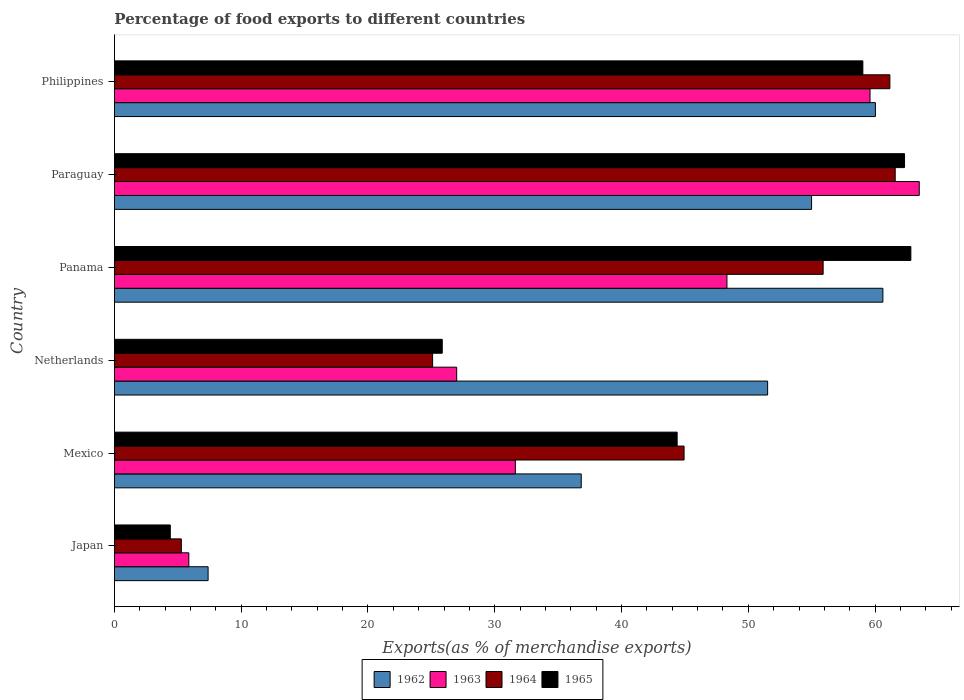How many different coloured bars are there?
Your response must be concise. 4. Are the number of bars on each tick of the Y-axis equal?
Your answer should be very brief. Yes. How many bars are there on the 4th tick from the top?
Provide a succinct answer. 4. What is the label of the 6th group of bars from the top?
Ensure brevity in your answer.  Japan. In how many cases, is the number of bars for a given country not equal to the number of legend labels?
Your answer should be very brief. 0. What is the percentage of exports to different countries in 1964 in Paraguay?
Your answer should be very brief. 61.59. Across all countries, what is the maximum percentage of exports to different countries in 1965?
Give a very brief answer. 62.82. Across all countries, what is the minimum percentage of exports to different countries in 1963?
Your answer should be very brief. 5.87. In which country was the percentage of exports to different countries in 1962 maximum?
Keep it short and to the point. Panama. What is the total percentage of exports to different countries in 1962 in the graph?
Provide a succinct answer. 271.37. What is the difference between the percentage of exports to different countries in 1962 in Japan and that in Mexico?
Your response must be concise. -29.43. What is the difference between the percentage of exports to different countries in 1962 in Japan and the percentage of exports to different countries in 1964 in Netherlands?
Your answer should be very brief. -17.71. What is the average percentage of exports to different countries in 1963 per country?
Give a very brief answer. 39.32. What is the difference between the percentage of exports to different countries in 1962 and percentage of exports to different countries in 1965 in Japan?
Offer a very short reply. 2.98. In how many countries, is the percentage of exports to different countries in 1963 greater than 4 %?
Your answer should be compact. 6. What is the ratio of the percentage of exports to different countries in 1963 in Japan to that in Mexico?
Offer a very short reply. 0.19. Is the difference between the percentage of exports to different countries in 1962 in Netherlands and Paraguay greater than the difference between the percentage of exports to different countries in 1965 in Netherlands and Paraguay?
Ensure brevity in your answer.  Yes. What is the difference between the highest and the second highest percentage of exports to different countries in 1963?
Your answer should be compact. 3.88. What is the difference between the highest and the lowest percentage of exports to different countries in 1963?
Keep it short and to the point. 57.62. Is it the case that in every country, the sum of the percentage of exports to different countries in 1964 and percentage of exports to different countries in 1962 is greater than the sum of percentage of exports to different countries in 1963 and percentage of exports to different countries in 1965?
Offer a very short reply. No. What does the 4th bar from the bottom in Mexico represents?
Your response must be concise. 1965. Are all the bars in the graph horizontal?
Offer a very short reply. Yes. What is the difference between two consecutive major ticks on the X-axis?
Your response must be concise. 10. Does the graph contain grids?
Offer a terse response. No. Where does the legend appear in the graph?
Provide a succinct answer. Bottom center. What is the title of the graph?
Provide a succinct answer. Percentage of food exports to different countries. What is the label or title of the X-axis?
Give a very brief answer. Exports(as % of merchandise exports). What is the Exports(as % of merchandise exports) of 1962 in Japan?
Offer a terse response. 7.39. What is the Exports(as % of merchandise exports) of 1963 in Japan?
Make the answer very short. 5.87. What is the Exports(as % of merchandise exports) in 1964 in Japan?
Give a very brief answer. 5.28. What is the Exports(as % of merchandise exports) in 1965 in Japan?
Make the answer very short. 4.41. What is the Exports(as % of merchandise exports) of 1962 in Mexico?
Offer a very short reply. 36.82. What is the Exports(as % of merchandise exports) in 1963 in Mexico?
Provide a succinct answer. 31.62. What is the Exports(as % of merchandise exports) of 1964 in Mexico?
Your response must be concise. 44.93. What is the Exports(as % of merchandise exports) in 1965 in Mexico?
Your answer should be very brief. 44.39. What is the Exports(as % of merchandise exports) in 1962 in Netherlands?
Ensure brevity in your answer.  51.52. What is the Exports(as % of merchandise exports) in 1963 in Netherlands?
Your answer should be compact. 27. What is the Exports(as % of merchandise exports) in 1964 in Netherlands?
Offer a very short reply. 25.1. What is the Exports(as % of merchandise exports) of 1965 in Netherlands?
Keep it short and to the point. 25.86. What is the Exports(as % of merchandise exports) in 1962 in Panama?
Provide a succinct answer. 60.62. What is the Exports(as % of merchandise exports) in 1963 in Panama?
Make the answer very short. 48.32. What is the Exports(as % of merchandise exports) of 1964 in Panama?
Make the answer very short. 55.9. What is the Exports(as % of merchandise exports) of 1965 in Panama?
Give a very brief answer. 62.82. What is the Exports(as % of merchandise exports) in 1962 in Paraguay?
Your answer should be very brief. 54.99. What is the Exports(as % of merchandise exports) of 1963 in Paraguay?
Provide a short and direct response. 63.48. What is the Exports(as % of merchandise exports) in 1964 in Paraguay?
Your response must be concise. 61.59. What is the Exports(as % of merchandise exports) in 1965 in Paraguay?
Give a very brief answer. 62.32. What is the Exports(as % of merchandise exports) of 1962 in Philippines?
Ensure brevity in your answer.  60.03. What is the Exports(as % of merchandise exports) of 1963 in Philippines?
Provide a succinct answer. 59.6. What is the Exports(as % of merchandise exports) in 1964 in Philippines?
Offer a terse response. 61.17. What is the Exports(as % of merchandise exports) in 1965 in Philippines?
Offer a terse response. 59.04. Across all countries, what is the maximum Exports(as % of merchandise exports) in 1962?
Your answer should be compact. 60.62. Across all countries, what is the maximum Exports(as % of merchandise exports) in 1963?
Offer a very short reply. 63.48. Across all countries, what is the maximum Exports(as % of merchandise exports) in 1964?
Ensure brevity in your answer.  61.59. Across all countries, what is the maximum Exports(as % of merchandise exports) in 1965?
Your response must be concise. 62.82. Across all countries, what is the minimum Exports(as % of merchandise exports) in 1962?
Offer a very short reply. 7.39. Across all countries, what is the minimum Exports(as % of merchandise exports) of 1963?
Provide a succinct answer. 5.87. Across all countries, what is the minimum Exports(as % of merchandise exports) in 1964?
Make the answer very short. 5.28. Across all countries, what is the minimum Exports(as % of merchandise exports) of 1965?
Your answer should be very brief. 4.41. What is the total Exports(as % of merchandise exports) of 1962 in the graph?
Your response must be concise. 271.37. What is the total Exports(as % of merchandise exports) in 1963 in the graph?
Offer a terse response. 235.89. What is the total Exports(as % of merchandise exports) of 1964 in the graph?
Provide a succinct answer. 253.97. What is the total Exports(as % of merchandise exports) in 1965 in the graph?
Make the answer very short. 258.83. What is the difference between the Exports(as % of merchandise exports) in 1962 in Japan and that in Mexico?
Give a very brief answer. -29.43. What is the difference between the Exports(as % of merchandise exports) of 1963 in Japan and that in Mexico?
Offer a very short reply. -25.75. What is the difference between the Exports(as % of merchandise exports) in 1964 in Japan and that in Mexico?
Ensure brevity in your answer.  -39.66. What is the difference between the Exports(as % of merchandise exports) of 1965 in Japan and that in Mexico?
Your answer should be very brief. -39.98. What is the difference between the Exports(as % of merchandise exports) of 1962 in Japan and that in Netherlands?
Offer a very short reply. -44.13. What is the difference between the Exports(as % of merchandise exports) of 1963 in Japan and that in Netherlands?
Offer a very short reply. -21.13. What is the difference between the Exports(as % of merchandise exports) of 1964 in Japan and that in Netherlands?
Provide a succinct answer. -19.82. What is the difference between the Exports(as % of merchandise exports) of 1965 in Japan and that in Netherlands?
Offer a terse response. -21.45. What is the difference between the Exports(as % of merchandise exports) of 1962 in Japan and that in Panama?
Ensure brevity in your answer.  -53.23. What is the difference between the Exports(as % of merchandise exports) of 1963 in Japan and that in Panama?
Offer a very short reply. -42.45. What is the difference between the Exports(as % of merchandise exports) of 1964 in Japan and that in Panama?
Offer a terse response. -50.63. What is the difference between the Exports(as % of merchandise exports) in 1965 in Japan and that in Panama?
Provide a short and direct response. -58.42. What is the difference between the Exports(as % of merchandise exports) in 1962 in Japan and that in Paraguay?
Provide a succinct answer. -47.6. What is the difference between the Exports(as % of merchandise exports) in 1963 in Japan and that in Paraguay?
Provide a short and direct response. -57.62. What is the difference between the Exports(as % of merchandise exports) of 1964 in Japan and that in Paraguay?
Ensure brevity in your answer.  -56.31. What is the difference between the Exports(as % of merchandise exports) in 1965 in Japan and that in Paraguay?
Your answer should be very brief. -57.92. What is the difference between the Exports(as % of merchandise exports) of 1962 in Japan and that in Philippines?
Your answer should be compact. -52.64. What is the difference between the Exports(as % of merchandise exports) in 1963 in Japan and that in Philippines?
Your answer should be compact. -53.73. What is the difference between the Exports(as % of merchandise exports) of 1964 in Japan and that in Philippines?
Give a very brief answer. -55.89. What is the difference between the Exports(as % of merchandise exports) of 1965 in Japan and that in Philippines?
Give a very brief answer. -54.63. What is the difference between the Exports(as % of merchandise exports) in 1962 in Mexico and that in Netherlands?
Ensure brevity in your answer.  -14.7. What is the difference between the Exports(as % of merchandise exports) of 1963 in Mexico and that in Netherlands?
Your response must be concise. 4.63. What is the difference between the Exports(as % of merchandise exports) in 1964 in Mexico and that in Netherlands?
Provide a short and direct response. 19.84. What is the difference between the Exports(as % of merchandise exports) of 1965 in Mexico and that in Netherlands?
Make the answer very short. 18.53. What is the difference between the Exports(as % of merchandise exports) of 1962 in Mexico and that in Panama?
Keep it short and to the point. -23.79. What is the difference between the Exports(as % of merchandise exports) of 1963 in Mexico and that in Panama?
Provide a succinct answer. -16.69. What is the difference between the Exports(as % of merchandise exports) in 1964 in Mexico and that in Panama?
Make the answer very short. -10.97. What is the difference between the Exports(as % of merchandise exports) in 1965 in Mexico and that in Panama?
Provide a short and direct response. -18.44. What is the difference between the Exports(as % of merchandise exports) in 1962 in Mexico and that in Paraguay?
Ensure brevity in your answer.  -18.17. What is the difference between the Exports(as % of merchandise exports) in 1963 in Mexico and that in Paraguay?
Ensure brevity in your answer.  -31.86. What is the difference between the Exports(as % of merchandise exports) in 1964 in Mexico and that in Paraguay?
Give a very brief answer. -16.65. What is the difference between the Exports(as % of merchandise exports) of 1965 in Mexico and that in Paraguay?
Offer a very short reply. -17.94. What is the difference between the Exports(as % of merchandise exports) in 1962 in Mexico and that in Philippines?
Ensure brevity in your answer.  -23.2. What is the difference between the Exports(as % of merchandise exports) of 1963 in Mexico and that in Philippines?
Offer a very short reply. -27.98. What is the difference between the Exports(as % of merchandise exports) in 1964 in Mexico and that in Philippines?
Offer a terse response. -16.23. What is the difference between the Exports(as % of merchandise exports) in 1965 in Mexico and that in Philippines?
Your response must be concise. -14.65. What is the difference between the Exports(as % of merchandise exports) of 1962 in Netherlands and that in Panama?
Ensure brevity in your answer.  -9.09. What is the difference between the Exports(as % of merchandise exports) in 1963 in Netherlands and that in Panama?
Provide a succinct answer. -21.32. What is the difference between the Exports(as % of merchandise exports) in 1964 in Netherlands and that in Panama?
Your answer should be very brief. -30.81. What is the difference between the Exports(as % of merchandise exports) of 1965 in Netherlands and that in Panama?
Ensure brevity in your answer.  -36.96. What is the difference between the Exports(as % of merchandise exports) of 1962 in Netherlands and that in Paraguay?
Make the answer very short. -3.47. What is the difference between the Exports(as % of merchandise exports) in 1963 in Netherlands and that in Paraguay?
Offer a terse response. -36.49. What is the difference between the Exports(as % of merchandise exports) of 1964 in Netherlands and that in Paraguay?
Your answer should be very brief. -36.49. What is the difference between the Exports(as % of merchandise exports) of 1965 in Netherlands and that in Paraguay?
Ensure brevity in your answer.  -36.47. What is the difference between the Exports(as % of merchandise exports) in 1962 in Netherlands and that in Philippines?
Give a very brief answer. -8.5. What is the difference between the Exports(as % of merchandise exports) in 1963 in Netherlands and that in Philippines?
Your answer should be very brief. -32.6. What is the difference between the Exports(as % of merchandise exports) of 1964 in Netherlands and that in Philippines?
Give a very brief answer. -36.07. What is the difference between the Exports(as % of merchandise exports) of 1965 in Netherlands and that in Philippines?
Offer a terse response. -33.18. What is the difference between the Exports(as % of merchandise exports) of 1962 in Panama and that in Paraguay?
Offer a very short reply. 5.62. What is the difference between the Exports(as % of merchandise exports) of 1963 in Panama and that in Paraguay?
Make the answer very short. -15.17. What is the difference between the Exports(as % of merchandise exports) in 1964 in Panama and that in Paraguay?
Your answer should be very brief. -5.68. What is the difference between the Exports(as % of merchandise exports) of 1965 in Panama and that in Paraguay?
Your answer should be compact. 0.5. What is the difference between the Exports(as % of merchandise exports) in 1962 in Panama and that in Philippines?
Your answer should be very brief. 0.59. What is the difference between the Exports(as % of merchandise exports) in 1963 in Panama and that in Philippines?
Offer a terse response. -11.29. What is the difference between the Exports(as % of merchandise exports) in 1964 in Panama and that in Philippines?
Your response must be concise. -5.26. What is the difference between the Exports(as % of merchandise exports) of 1965 in Panama and that in Philippines?
Provide a short and direct response. 3.79. What is the difference between the Exports(as % of merchandise exports) in 1962 in Paraguay and that in Philippines?
Offer a very short reply. -5.03. What is the difference between the Exports(as % of merchandise exports) in 1963 in Paraguay and that in Philippines?
Your response must be concise. 3.88. What is the difference between the Exports(as % of merchandise exports) of 1964 in Paraguay and that in Philippines?
Give a very brief answer. 0.42. What is the difference between the Exports(as % of merchandise exports) in 1965 in Paraguay and that in Philippines?
Offer a very short reply. 3.29. What is the difference between the Exports(as % of merchandise exports) in 1962 in Japan and the Exports(as % of merchandise exports) in 1963 in Mexico?
Offer a terse response. -24.23. What is the difference between the Exports(as % of merchandise exports) of 1962 in Japan and the Exports(as % of merchandise exports) of 1964 in Mexico?
Provide a short and direct response. -37.55. What is the difference between the Exports(as % of merchandise exports) of 1962 in Japan and the Exports(as % of merchandise exports) of 1965 in Mexico?
Ensure brevity in your answer.  -37. What is the difference between the Exports(as % of merchandise exports) in 1963 in Japan and the Exports(as % of merchandise exports) in 1964 in Mexico?
Make the answer very short. -39.07. What is the difference between the Exports(as % of merchandise exports) of 1963 in Japan and the Exports(as % of merchandise exports) of 1965 in Mexico?
Offer a very short reply. -38.52. What is the difference between the Exports(as % of merchandise exports) of 1964 in Japan and the Exports(as % of merchandise exports) of 1965 in Mexico?
Your response must be concise. -39.11. What is the difference between the Exports(as % of merchandise exports) in 1962 in Japan and the Exports(as % of merchandise exports) in 1963 in Netherlands?
Your answer should be very brief. -19.61. What is the difference between the Exports(as % of merchandise exports) of 1962 in Japan and the Exports(as % of merchandise exports) of 1964 in Netherlands?
Your response must be concise. -17.71. What is the difference between the Exports(as % of merchandise exports) in 1962 in Japan and the Exports(as % of merchandise exports) in 1965 in Netherlands?
Ensure brevity in your answer.  -18.47. What is the difference between the Exports(as % of merchandise exports) of 1963 in Japan and the Exports(as % of merchandise exports) of 1964 in Netherlands?
Keep it short and to the point. -19.23. What is the difference between the Exports(as % of merchandise exports) in 1963 in Japan and the Exports(as % of merchandise exports) in 1965 in Netherlands?
Provide a short and direct response. -19.99. What is the difference between the Exports(as % of merchandise exports) of 1964 in Japan and the Exports(as % of merchandise exports) of 1965 in Netherlands?
Make the answer very short. -20.58. What is the difference between the Exports(as % of merchandise exports) in 1962 in Japan and the Exports(as % of merchandise exports) in 1963 in Panama?
Make the answer very short. -40.93. What is the difference between the Exports(as % of merchandise exports) of 1962 in Japan and the Exports(as % of merchandise exports) of 1964 in Panama?
Your response must be concise. -48.51. What is the difference between the Exports(as % of merchandise exports) in 1962 in Japan and the Exports(as % of merchandise exports) in 1965 in Panama?
Offer a terse response. -55.43. What is the difference between the Exports(as % of merchandise exports) of 1963 in Japan and the Exports(as % of merchandise exports) of 1964 in Panama?
Keep it short and to the point. -50.03. What is the difference between the Exports(as % of merchandise exports) in 1963 in Japan and the Exports(as % of merchandise exports) in 1965 in Panama?
Give a very brief answer. -56.95. What is the difference between the Exports(as % of merchandise exports) of 1964 in Japan and the Exports(as % of merchandise exports) of 1965 in Panama?
Give a very brief answer. -57.54. What is the difference between the Exports(as % of merchandise exports) of 1962 in Japan and the Exports(as % of merchandise exports) of 1963 in Paraguay?
Give a very brief answer. -56.1. What is the difference between the Exports(as % of merchandise exports) of 1962 in Japan and the Exports(as % of merchandise exports) of 1964 in Paraguay?
Give a very brief answer. -54.2. What is the difference between the Exports(as % of merchandise exports) in 1962 in Japan and the Exports(as % of merchandise exports) in 1965 in Paraguay?
Offer a terse response. -54.94. What is the difference between the Exports(as % of merchandise exports) in 1963 in Japan and the Exports(as % of merchandise exports) in 1964 in Paraguay?
Your answer should be very brief. -55.72. What is the difference between the Exports(as % of merchandise exports) in 1963 in Japan and the Exports(as % of merchandise exports) in 1965 in Paraguay?
Provide a succinct answer. -56.46. What is the difference between the Exports(as % of merchandise exports) in 1964 in Japan and the Exports(as % of merchandise exports) in 1965 in Paraguay?
Offer a very short reply. -57.05. What is the difference between the Exports(as % of merchandise exports) in 1962 in Japan and the Exports(as % of merchandise exports) in 1963 in Philippines?
Ensure brevity in your answer.  -52.21. What is the difference between the Exports(as % of merchandise exports) of 1962 in Japan and the Exports(as % of merchandise exports) of 1964 in Philippines?
Ensure brevity in your answer.  -53.78. What is the difference between the Exports(as % of merchandise exports) of 1962 in Japan and the Exports(as % of merchandise exports) of 1965 in Philippines?
Offer a very short reply. -51.65. What is the difference between the Exports(as % of merchandise exports) in 1963 in Japan and the Exports(as % of merchandise exports) in 1964 in Philippines?
Your answer should be compact. -55.3. What is the difference between the Exports(as % of merchandise exports) in 1963 in Japan and the Exports(as % of merchandise exports) in 1965 in Philippines?
Provide a short and direct response. -53.17. What is the difference between the Exports(as % of merchandise exports) in 1964 in Japan and the Exports(as % of merchandise exports) in 1965 in Philippines?
Your response must be concise. -53.76. What is the difference between the Exports(as % of merchandise exports) of 1962 in Mexico and the Exports(as % of merchandise exports) of 1963 in Netherlands?
Give a very brief answer. 9.83. What is the difference between the Exports(as % of merchandise exports) in 1962 in Mexico and the Exports(as % of merchandise exports) in 1964 in Netherlands?
Your answer should be compact. 11.72. What is the difference between the Exports(as % of merchandise exports) of 1962 in Mexico and the Exports(as % of merchandise exports) of 1965 in Netherlands?
Offer a terse response. 10.96. What is the difference between the Exports(as % of merchandise exports) of 1963 in Mexico and the Exports(as % of merchandise exports) of 1964 in Netherlands?
Your response must be concise. 6.53. What is the difference between the Exports(as % of merchandise exports) in 1963 in Mexico and the Exports(as % of merchandise exports) in 1965 in Netherlands?
Provide a succinct answer. 5.77. What is the difference between the Exports(as % of merchandise exports) of 1964 in Mexico and the Exports(as % of merchandise exports) of 1965 in Netherlands?
Offer a very short reply. 19.08. What is the difference between the Exports(as % of merchandise exports) in 1962 in Mexico and the Exports(as % of merchandise exports) in 1963 in Panama?
Keep it short and to the point. -11.49. What is the difference between the Exports(as % of merchandise exports) of 1962 in Mexico and the Exports(as % of merchandise exports) of 1964 in Panama?
Offer a very short reply. -19.08. What is the difference between the Exports(as % of merchandise exports) of 1962 in Mexico and the Exports(as % of merchandise exports) of 1965 in Panama?
Keep it short and to the point. -26. What is the difference between the Exports(as % of merchandise exports) in 1963 in Mexico and the Exports(as % of merchandise exports) in 1964 in Panama?
Your response must be concise. -24.28. What is the difference between the Exports(as % of merchandise exports) in 1963 in Mexico and the Exports(as % of merchandise exports) in 1965 in Panama?
Give a very brief answer. -31.2. What is the difference between the Exports(as % of merchandise exports) in 1964 in Mexico and the Exports(as % of merchandise exports) in 1965 in Panama?
Your answer should be very brief. -17.89. What is the difference between the Exports(as % of merchandise exports) of 1962 in Mexico and the Exports(as % of merchandise exports) of 1963 in Paraguay?
Give a very brief answer. -26.66. What is the difference between the Exports(as % of merchandise exports) of 1962 in Mexico and the Exports(as % of merchandise exports) of 1964 in Paraguay?
Provide a succinct answer. -24.76. What is the difference between the Exports(as % of merchandise exports) in 1962 in Mexico and the Exports(as % of merchandise exports) in 1965 in Paraguay?
Provide a short and direct response. -25.5. What is the difference between the Exports(as % of merchandise exports) in 1963 in Mexico and the Exports(as % of merchandise exports) in 1964 in Paraguay?
Your answer should be very brief. -29.96. What is the difference between the Exports(as % of merchandise exports) in 1963 in Mexico and the Exports(as % of merchandise exports) in 1965 in Paraguay?
Provide a short and direct response. -30.7. What is the difference between the Exports(as % of merchandise exports) in 1964 in Mexico and the Exports(as % of merchandise exports) in 1965 in Paraguay?
Provide a short and direct response. -17.39. What is the difference between the Exports(as % of merchandise exports) of 1962 in Mexico and the Exports(as % of merchandise exports) of 1963 in Philippines?
Your answer should be very brief. -22.78. What is the difference between the Exports(as % of merchandise exports) in 1962 in Mexico and the Exports(as % of merchandise exports) in 1964 in Philippines?
Provide a succinct answer. -24.34. What is the difference between the Exports(as % of merchandise exports) of 1962 in Mexico and the Exports(as % of merchandise exports) of 1965 in Philippines?
Make the answer very short. -22.21. What is the difference between the Exports(as % of merchandise exports) of 1963 in Mexico and the Exports(as % of merchandise exports) of 1964 in Philippines?
Offer a very short reply. -29.54. What is the difference between the Exports(as % of merchandise exports) of 1963 in Mexico and the Exports(as % of merchandise exports) of 1965 in Philippines?
Your response must be concise. -27.41. What is the difference between the Exports(as % of merchandise exports) in 1964 in Mexico and the Exports(as % of merchandise exports) in 1965 in Philippines?
Keep it short and to the point. -14.1. What is the difference between the Exports(as % of merchandise exports) of 1962 in Netherlands and the Exports(as % of merchandise exports) of 1963 in Panama?
Provide a succinct answer. 3.21. What is the difference between the Exports(as % of merchandise exports) in 1962 in Netherlands and the Exports(as % of merchandise exports) in 1964 in Panama?
Your answer should be compact. -4.38. What is the difference between the Exports(as % of merchandise exports) in 1962 in Netherlands and the Exports(as % of merchandise exports) in 1965 in Panama?
Your answer should be compact. -11.3. What is the difference between the Exports(as % of merchandise exports) in 1963 in Netherlands and the Exports(as % of merchandise exports) in 1964 in Panama?
Your answer should be very brief. -28.91. What is the difference between the Exports(as % of merchandise exports) of 1963 in Netherlands and the Exports(as % of merchandise exports) of 1965 in Panama?
Your response must be concise. -35.82. What is the difference between the Exports(as % of merchandise exports) in 1964 in Netherlands and the Exports(as % of merchandise exports) in 1965 in Panama?
Your response must be concise. -37.72. What is the difference between the Exports(as % of merchandise exports) of 1962 in Netherlands and the Exports(as % of merchandise exports) of 1963 in Paraguay?
Make the answer very short. -11.96. What is the difference between the Exports(as % of merchandise exports) of 1962 in Netherlands and the Exports(as % of merchandise exports) of 1964 in Paraguay?
Ensure brevity in your answer.  -10.06. What is the difference between the Exports(as % of merchandise exports) in 1962 in Netherlands and the Exports(as % of merchandise exports) in 1965 in Paraguay?
Ensure brevity in your answer.  -10.8. What is the difference between the Exports(as % of merchandise exports) of 1963 in Netherlands and the Exports(as % of merchandise exports) of 1964 in Paraguay?
Your response must be concise. -34.59. What is the difference between the Exports(as % of merchandise exports) of 1963 in Netherlands and the Exports(as % of merchandise exports) of 1965 in Paraguay?
Your response must be concise. -35.33. What is the difference between the Exports(as % of merchandise exports) in 1964 in Netherlands and the Exports(as % of merchandise exports) in 1965 in Paraguay?
Your response must be concise. -37.23. What is the difference between the Exports(as % of merchandise exports) of 1962 in Netherlands and the Exports(as % of merchandise exports) of 1963 in Philippines?
Your response must be concise. -8.08. What is the difference between the Exports(as % of merchandise exports) in 1962 in Netherlands and the Exports(as % of merchandise exports) in 1964 in Philippines?
Make the answer very short. -9.64. What is the difference between the Exports(as % of merchandise exports) of 1962 in Netherlands and the Exports(as % of merchandise exports) of 1965 in Philippines?
Provide a short and direct response. -7.51. What is the difference between the Exports(as % of merchandise exports) in 1963 in Netherlands and the Exports(as % of merchandise exports) in 1964 in Philippines?
Provide a short and direct response. -34.17. What is the difference between the Exports(as % of merchandise exports) in 1963 in Netherlands and the Exports(as % of merchandise exports) in 1965 in Philippines?
Ensure brevity in your answer.  -32.04. What is the difference between the Exports(as % of merchandise exports) of 1964 in Netherlands and the Exports(as % of merchandise exports) of 1965 in Philippines?
Provide a short and direct response. -33.94. What is the difference between the Exports(as % of merchandise exports) of 1962 in Panama and the Exports(as % of merchandise exports) of 1963 in Paraguay?
Provide a succinct answer. -2.87. What is the difference between the Exports(as % of merchandise exports) of 1962 in Panama and the Exports(as % of merchandise exports) of 1964 in Paraguay?
Provide a succinct answer. -0.97. What is the difference between the Exports(as % of merchandise exports) of 1962 in Panama and the Exports(as % of merchandise exports) of 1965 in Paraguay?
Provide a short and direct response. -1.71. What is the difference between the Exports(as % of merchandise exports) of 1963 in Panama and the Exports(as % of merchandise exports) of 1964 in Paraguay?
Offer a very short reply. -13.27. What is the difference between the Exports(as % of merchandise exports) of 1963 in Panama and the Exports(as % of merchandise exports) of 1965 in Paraguay?
Make the answer very short. -14.01. What is the difference between the Exports(as % of merchandise exports) of 1964 in Panama and the Exports(as % of merchandise exports) of 1965 in Paraguay?
Offer a very short reply. -6.42. What is the difference between the Exports(as % of merchandise exports) in 1962 in Panama and the Exports(as % of merchandise exports) in 1963 in Philippines?
Your answer should be very brief. 1.01. What is the difference between the Exports(as % of merchandise exports) of 1962 in Panama and the Exports(as % of merchandise exports) of 1964 in Philippines?
Your answer should be compact. -0.55. What is the difference between the Exports(as % of merchandise exports) in 1962 in Panama and the Exports(as % of merchandise exports) in 1965 in Philippines?
Your answer should be very brief. 1.58. What is the difference between the Exports(as % of merchandise exports) of 1963 in Panama and the Exports(as % of merchandise exports) of 1964 in Philippines?
Provide a short and direct response. -12.85. What is the difference between the Exports(as % of merchandise exports) of 1963 in Panama and the Exports(as % of merchandise exports) of 1965 in Philippines?
Keep it short and to the point. -10.72. What is the difference between the Exports(as % of merchandise exports) in 1964 in Panama and the Exports(as % of merchandise exports) in 1965 in Philippines?
Your answer should be very brief. -3.13. What is the difference between the Exports(as % of merchandise exports) of 1962 in Paraguay and the Exports(as % of merchandise exports) of 1963 in Philippines?
Provide a short and direct response. -4.61. What is the difference between the Exports(as % of merchandise exports) in 1962 in Paraguay and the Exports(as % of merchandise exports) in 1964 in Philippines?
Make the answer very short. -6.18. What is the difference between the Exports(as % of merchandise exports) in 1962 in Paraguay and the Exports(as % of merchandise exports) in 1965 in Philippines?
Make the answer very short. -4.04. What is the difference between the Exports(as % of merchandise exports) of 1963 in Paraguay and the Exports(as % of merchandise exports) of 1964 in Philippines?
Your response must be concise. 2.32. What is the difference between the Exports(as % of merchandise exports) in 1963 in Paraguay and the Exports(as % of merchandise exports) in 1965 in Philippines?
Give a very brief answer. 4.45. What is the difference between the Exports(as % of merchandise exports) of 1964 in Paraguay and the Exports(as % of merchandise exports) of 1965 in Philippines?
Ensure brevity in your answer.  2.55. What is the average Exports(as % of merchandise exports) in 1962 per country?
Ensure brevity in your answer.  45.23. What is the average Exports(as % of merchandise exports) in 1963 per country?
Keep it short and to the point. 39.32. What is the average Exports(as % of merchandise exports) in 1964 per country?
Give a very brief answer. 42.33. What is the average Exports(as % of merchandise exports) in 1965 per country?
Your answer should be compact. 43.14. What is the difference between the Exports(as % of merchandise exports) of 1962 and Exports(as % of merchandise exports) of 1963 in Japan?
Make the answer very short. 1.52. What is the difference between the Exports(as % of merchandise exports) in 1962 and Exports(as % of merchandise exports) in 1964 in Japan?
Offer a terse response. 2.11. What is the difference between the Exports(as % of merchandise exports) of 1962 and Exports(as % of merchandise exports) of 1965 in Japan?
Provide a succinct answer. 2.98. What is the difference between the Exports(as % of merchandise exports) of 1963 and Exports(as % of merchandise exports) of 1964 in Japan?
Offer a terse response. 0.59. What is the difference between the Exports(as % of merchandise exports) in 1963 and Exports(as % of merchandise exports) in 1965 in Japan?
Ensure brevity in your answer.  1.46. What is the difference between the Exports(as % of merchandise exports) in 1964 and Exports(as % of merchandise exports) in 1965 in Japan?
Make the answer very short. 0.87. What is the difference between the Exports(as % of merchandise exports) in 1962 and Exports(as % of merchandise exports) in 1963 in Mexico?
Keep it short and to the point. 5.2. What is the difference between the Exports(as % of merchandise exports) in 1962 and Exports(as % of merchandise exports) in 1964 in Mexico?
Provide a short and direct response. -8.11. What is the difference between the Exports(as % of merchandise exports) of 1962 and Exports(as % of merchandise exports) of 1965 in Mexico?
Your answer should be compact. -7.56. What is the difference between the Exports(as % of merchandise exports) of 1963 and Exports(as % of merchandise exports) of 1964 in Mexico?
Offer a terse response. -13.31. What is the difference between the Exports(as % of merchandise exports) in 1963 and Exports(as % of merchandise exports) in 1965 in Mexico?
Your response must be concise. -12.76. What is the difference between the Exports(as % of merchandise exports) of 1964 and Exports(as % of merchandise exports) of 1965 in Mexico?
Give a very brief answer. 0.55. What is the difference between the Exports(as % of merchandise exports) in 1962 and Exports(as % of merchandise exports) in 1963 in Netherlands?
Provide a short and direct response. 24.53. What is the difference between the Exports(as % of merchandise exports) of 1962 and Exports(as % of merchandise exports) of 1964 in Netherlands?
Provide a short and direct response. 26.43. What is the difference between the Exports(as % of merchandise exports) of 1962 and Exports(as % of merchandise exports) of 1965 in Netherlands?
Give a very brief answer. 25.67. What is the difference between the Exports(as % of merchandise exports) in 1963 and Exports(as % of merchandise exports) in 1964 in Netherlands?
Provide a short and direct response. 1.9. What is the difference between the Exports(as % of merchandise exports) of 1963 and Exports(as % of merchandise exports) of 1965 in Netherlands?
Give a very brief answer. 1.14. What is the difference between the Exports(as % of merchandise exports) of 1964 and Exports(as % of merchandise exports) of 1965 in Netherlands?
Offer a very short reply. -0.76. What is the difference between the Exports(as % of merchandise exports) in 1962 and Exports(as % of merchandise exports) in 1963 in Panama?
Make the answer very short. 12.3. What is the difference between the Exports(as % of merchandise exports) in 1962 and Exports(as % of merchandise exports) in 1964 in Panama?
Ensure brevity in your answer.  4.71. What is the difference between the Exports(as % of merchandise exports) in 1962 and Exports(as % of merchandise exports) in 1965 in Panama?
Provide a short and direct response. -2.21. What is the difference between the Exports(as % of merchandise exports) in 1963 and Exports(as % of merchandise exports) in 1964 in Panama?
Give a very brief answer. -7.59. What is the difference between the Exports(as % of merchandise exports) in 1963 and Exports(as % of merchandise exports) in 1965 in Panama?
Provide a succinct answer. -14.51. What is the difference between the Exports(as % of merchandise exports) of 1964 and Exports(as % of merchandise exports) of 1965 in Panama?
Ensure brevity in your answer.  -6.92. What is the difference between the Exports(as % of merchandise exports) of 1962 and Exports(as % of merchandise exports) of 1963 in Paraguay?
Provide a succinct answer. -8.49. What is the difference between the Exports(as % of merchandise exports) in 1962 and Exports(as % of merchandise exports) in 1964 in Paraguay?
Your answer should be compact. -6.6. What is the difference between the Exports(as % of merchandise exports) of 1962 and Exports(as % of merchandise exports) of 1965 in Paraguay?
Keep it short and to the point. -7.33. What is the difference between the Exports(as % of merchandise exports) in 1963 and Exports(as % of merchandise exports) in 1964 in Paraguay?
Your response must be concise. 1.9. What is the difference between the Exports(as % of merchandise exports) of 1963 and Exports(as % of merchandise exports) of 1965 in Paraguay?
Provide a short and direct response. 1.16. What is the difference between the Exports(as % of merchandise exports) in 1964 and Exports(as % of merchandise exports) in 1965 in Paraguay?
Keep it short and to the point. -0.74. What is the difference between the Exports(as % of merchandise exports) of 1962 and Exports(as % of merchandise exports) of 1963 in Philippines?
Provide a short and direct response. 0.42. What is the difference between the Exports(as % of merchandise exports) of 1962 and Exports(as % of merchandise exports) of 1964 in Philippines?
Make the answer very short. -1.14. What is the difference between the Exports(as % of merchandise exports) in 1962 and Exports(as % of merchandise exports) in 1965 in Philippines?
Keep it short and to the point. 0.99. What is the difference between the Exports(as % of merchandise exports) in 1963 and Exports(as % of merchandise exports) in 1964 in Philippines?
Make the answer very short. -1.57. What is the difference between the Exports(as % of merchandise exports) of 1963 and Exports(as % of merchandise exports) of 1965 in Philippines?
Provide a short and direct response. 0.57. What is the difference between the Exports(as % of merchandise exports) in 1964 and Exports(as % of merchandise exports) in 1965 in Philippines?
Make the answer very short. 2.13. What is the ratio of the Exports(as % of merchandise exports) of 1962 in Japan to that in Mexico?
Offer a terse response. 0.2. What is the ratio of the Exports(as % of merchandise exports) of 1963 in Japan to that in Mexico?
Ensure brevity in your answer.  0.19. What is the ratio of the Exports(as % of merchandise exports) of 1964 in Japan to that in Mexico?
Offer a very short reply. 0.12. What is the ratio of the Exports(as % of merchandise exports) of 1965 in Japan to that in Mexico?
Your response must be concise. 0.1. What is the ratio of the Exports(as % of merchandise exports) in 1962 in Japan to that in Netherlands?
Your response must be concise. 0.14. What is the ratio of the Exports(as % of merchandise exports) of 1963 in Japan to that in Netherlands?
Offer a terse response. 0.22. What is the ratio of the Exports(as % of merchandise exports) of 1964 in Japan to that in Netherlands?
Provide a short and direct response. 0.21. What is the ratio of the Exports(as % of merchandise exports) in 1965 in Japan to that in Netherlands?
Offer a very short reply. 0.17. What is the ratio of the Exports(as % of merchandise exports) in 1962 in Japan to that in Panama?
Offer a very short reply. 0.12. What is the ratio of the Exports(as % of merchandise exports) in 1963 in Japan to that in Panama?
Make the answer very short. 0.12. What is the ratio of the Exports(as % of merchandise exports) of 1964 in Japan to that in Panama?
Offer a terse response. 0.09. What is the ratio of the Exports(as % of merchandise exports) of 1965 in Japan to that in Panama?
Offer a terse response. 0.07. What is the ratio of the Exports(as % of merchandise exports) in 1962 in Japan to that in Paraguay?
Keep it short and to the point. 0.13. What is the ratio of the Exports(as % of merchandise exports) of 1963 in Japan to that in Paraguay?
Give a very brief answer. 0.09. What is the ratio of the Exports(as % of merchandise exports) of 1964 in Japan to that in Paraguay?
Your response must be concise. 0.09. What is the ratio of the Exports(as % of merchandise exports) of 1965 in Japan to that in Paraguay?
Your answer should be very brief. 0.07. What is the ratio of the Exports(as % of merchandise exports) of 1962 in Japan to that in Philippines?
Your answer should be compact. 0.12. What is the ratio of the Exports(as % of merchandise exports) of 1963 in Japan to that in Philippines?
Keep it short and to the point. 0.1. What is the ratio of the Exports(as % of merchandise exports) of 1964 in Japan to that in Philippines?
Provide a short and direct response. 0.09. What is the ratio of the Exports(as % of merchandise exports) of 1965 in Japan to that in Philippines?
Provide a succinct answer. 0.07. What is the ratio of the Exports(as % of merchandise exports) in 1962 in Mexico to that in Netherlands?
Provide a short and direct response. 0.71. What is the ratio of the Exports(as % of merchandise exports) in 1963 in Mexico to that in Netherlands?
Your answer should be compact. 1.17. What is the ratio of the Exports(as % of merchandise exports) in 1964 in Mexico to that in Netherlands?
Offer a very short reply. 1.79. What is the ratio of the Exports(as % of merchandise exports) of 1965 in Mexico to that in Netherlands?
Ensure brevity in your answer.  1.72. What is the ratio of the Exports(as % of merchandise exports) in 1962 in Mexico to that in Panama?
Your response must be concise. 0.61. What is the ratio of the Exports(as % of merchandise exports) in 1963 in Mexico to that in Panama?
Your answer should be compact. 0.65. What is the ratio of the Exports(as % of merchandise exports) in 1964 in Mexico to that in Panama?
Your answer should be compact. 0.8. What is the ratio of the Exports(as % of merchandise exports) in 1965 in Mexico to that in Panama?
Keep it short and to the point. 0.71. What is the ratio of the Exports(as % of merchandise exports) in 1962 in Mexico to that in Paraguay?
Your response must be concise. 0.67. What is the ratio of the Exports(as % of merchandise exports) of 1963 in Mexico to that in Paraguay?
Offer a terse response. 0.5. What is the ratio of the Exports(as % of merchandise exports) in 1964 in Mexico to that in Paraguay?
Provide a succinct answer. 0.73. What is the ratio of the Exports(as % of merchandise exports) of 1965 in Mexico to that in Paraguay?
Provide a succinct answer. 0.71. What is the ratio of the Exports(as % of merchandise exports) in 1962 in Mexico to that in Philippines?
Offer a terse response. 0.61. What is the ratio of the Exports(as % of merchandise exports) in 1963 in Mexico to that in Philippines?
Ensure brevity in your answer.  0.53. What is the ratio of the Exports(as % of merchandise exports) of 1964 in Mexico to that in Philippines?
Your response must be concise. 0.73. What is the ratio of the Exports(as % of merchandise exports) of 1965 in Mexico to that in Philippines?
Offer a very short reply. 0.75. What is the ratio of the Exports(as % of merchandise exports) of 1962 in Netherlands to that in Panama?
Provide a succinct answer. 0.85. What is the ratio of the Exports(as % of merchandise exports) in 1963 in Netherlands to that in Panama?
Your answer should be compact. 0.56. What is the ratio of the Exports(as % of merchandise exports) of 1964 in Netherlands to that in Panama?
Offer a very short reply. 0.45. What is the ratio of the Exports(as % of merchandise exports) of 1965 in Netherlands to that in Panama?
Your response must be concise. 0.41. What is the ratio of the Exports(as % of merchandise exports) of 1962 in Netherlands to that in Paraguay?
Provide a succinct answer. 0.94. What is the ratio of the Exports(as % of merchandise exports) in 1963 in Netherlands to that in Paraguay?
Offer a very short reply. 0.43. What is the ratio of the Exports(as % of merchandise exports) of 1964 in Netherlands to that in Paraguay?
Ensure brevity in your answer.  0.41. What is the ratio of the Exports(as % of merchandise exports) in 1965 in Netherlands to that in Paraguay?
Ensure brevity in your answer.  0.41. What is the ratio of the Exports(as % of merchandise exports) of 1962 in Netherlands to that in Philippines?
Make the answer very short. 0.86. What is the ratio of the Exports(as % of merchandise exports) of 1963 in Netherlands to that in Philippines?
Provide a succinct answer. 0.45. What is the ratio of the Exports(as % of merchandise exports) of 1964 in Netherlands to that in Philippines?
Your answer should be very brief. 0.41. What is the ratio of the Exports(as % of merchandise exports) of 1965 in Netherlands to that in Philippines?
Ensure brevity in your answer.  0.44. What is the ratio of the Exports(as % of merchandise exports) of 1962 in Panama to that in Paraguay?
Provide a succinct answer. 1.1. What is the ratio of the Exports(as % of merchandise exports) in 1963 in Panama to that in Paraguay?
Your answer should be compact. 0.76. What is the ratio of the Exports(as % of merchandise exports) in 1964 in Panama to that in Paraguay?
Offer a terse response. 0.91. What is the ratio of the Exports(as % of merchandise exports) of 1962 in Panama to that in Philippines?
Make the answer very short. 1.01. What is the ratio of the Exports(as % of merchandise exports) of 1963 in Panama to that in Philippines?
Offer a very short reply. 0.81. What is the ratio of the Exports(as % of merchandise exports) in 1964 in Panama to that in Philippines?
Offer a terse response. 0.91. What is the ratio of the Exports(as % of merchandise exports) in 1965 in Panama to that in Philippines?
Your response must be concise. 1.06. What is the ratio of the Exports(as % of merchandise exports) of 1962 in Paraguay to that in Philippines?
Offer a very short reply. 0.92. What is the ratio of the Exports(as % of merchandise exports) in 1963 in Paraguay to that in Philippines?
Offer a terse response. 1.07. What is the ratio of the Exports(as % of merchandise exports) in 1965 in Paraguay to that in Philippines?
Your response must be concise. 1.06. What is the difference between the highest and the second highest Exports(as % of merchandise exports) in 1962?
Your answer should be compact. 0.59. What is the difference between the highest and the second highest Exports(as % of merchandise exports) of 1963?
Keep it short and to the point. 3.88. What is the difference between the highest and the second highest Exports(as % of merchandise exports) of 1964?
Your response must be concise. 0.42. What is the difference between the highest and the second highest Exports(as % of merchandise exports) in 1965?
Provide a short and direct response. 0.5. What is the difference between the highest and the lowest Exports(as % of merchandise exports) in 1962?
Make the answer very short. 53.23. What is the difference between the highest and the lowest Exports(as % of merchandise exports) of 1963?
Give a very brief answer. 57.62. What is the difference between the highest and the lowest Exports(as % of merchandise exports) in 1964?
Provide a short and direct response. 56.31. What is the difference between the highest and the lowest Exports(as % of merchandise exports) in 1965?
Your response must be concise. 58.42. 